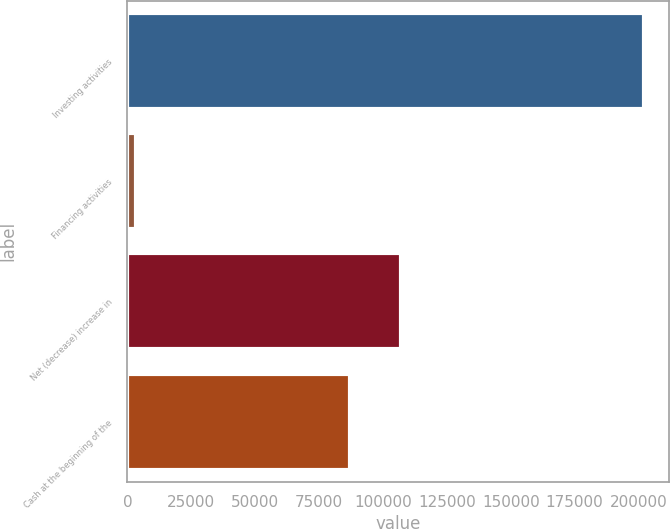Convert chart to OTSL. <chart><loc_0><loc_0><loc_500><loc_500><bar_chart><fcel>Investing activities<fcel>Financing activities<fcel>Net (decrease) increase in<fcel>Cash at the beginning of the<nl><fcel>201986<fcel>3353<fcel>107102<fcel>87239<nl></chart> 